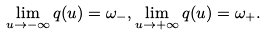Convert formula to latex. <formula><loc_0><loc_0><loc_500><loc_500>\lim _ { u \to - \infty } q ( u ) = \omega _ { - } , \lim _ { u \to + \infty } q ( u ) = \omega _ { + } .</formula> 